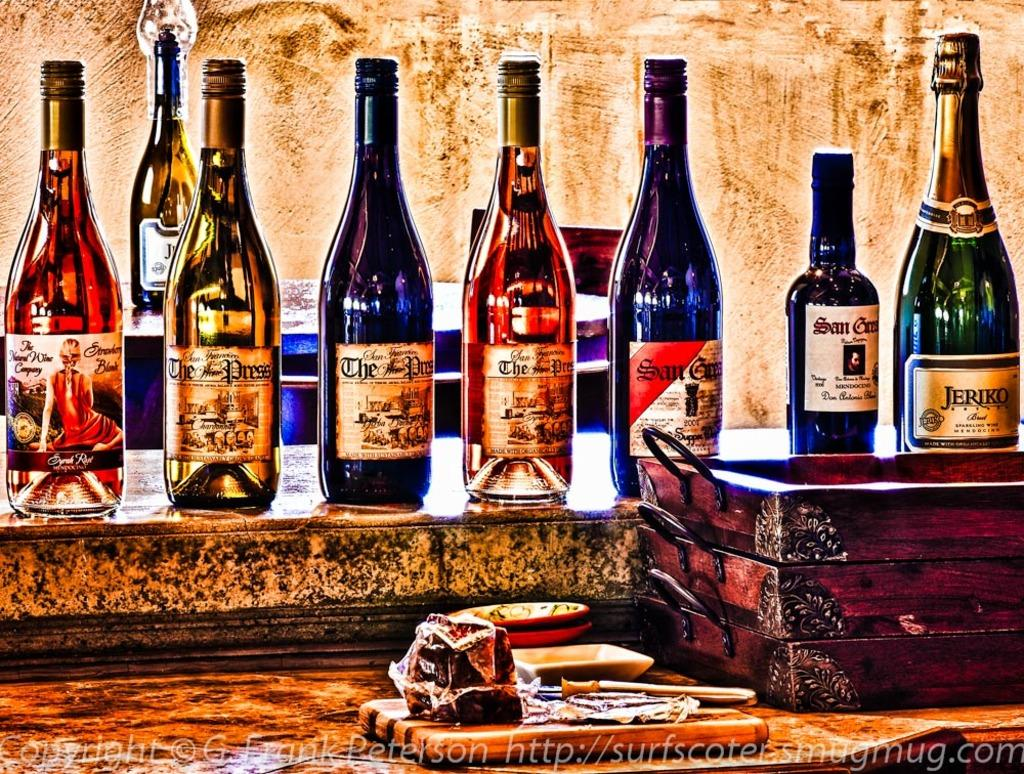Provide a one-sentence caption for the provided image. a painting of many wines has a bottle from the natural wine company. 